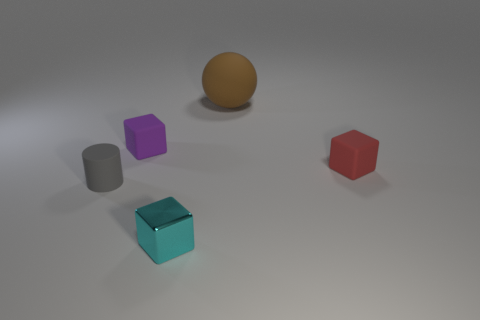Are any large blue blocks visible?
Keep it short and to the point. No. Are there more purple cubes that are in front of the metallic cube than spheres to the left of the gray matte object?
Your response must be concise. No. There is a rubber cube behind the thing that is to the right of the brown matte sphere; what color is it?
Offer a very short reply. Purple. Are there any spheres that have the same color as the small cylinder?
Provide a short and direct response. No. There is a object left of the tiny object behind the tiny matte cube to the right of the matte ball; what is its size?
Ensure brevity in your answer.  Small. What shape is the gray object?
Your answer should be very brief. Cylinder. How many blocks are in front of the cube to the left of the cyan metal block?
Keep it short and to the point. 2. How many other objects are the same material as the purple object?
Make the answer very short. 3. Is the tiny thing that is left of the purple rubber object made of the same material as the cube that is in front of the small cylinder?
Your answer should be very brief. No. Is there any other thing that is the same shape as the big rubber object?
Your answer should be very brief. No. 